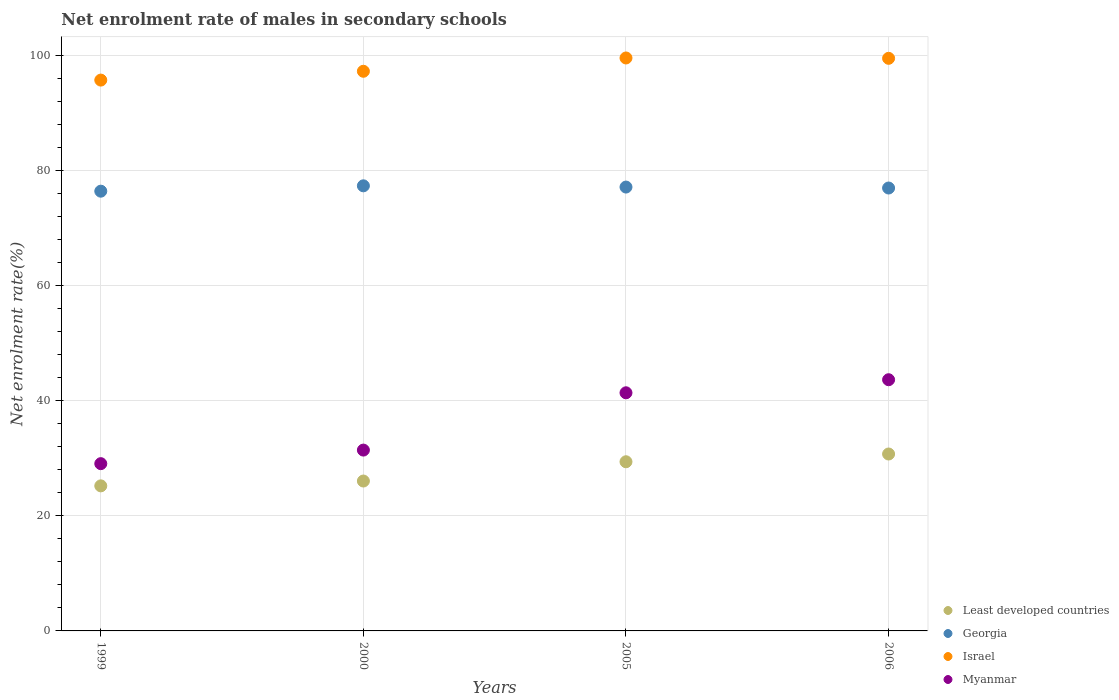What is the net enrolment rate of males in secondary schools in Israel in 2005?
Make the answer very short. 99.56. Across all years, what is the maximum net enrolment rate of males in secondary schools in Myanmar?
Ensure brevity in your answer.  43.65. Across all years, what is the minimum net enrolment rate of males in secondary schools in Least developed countries?
Your answer should be very brief. 25.21. What is the total net enrolment rate of males in secondary schools in Israel in the graph?
Ensure brevity in your answer.  392.01. What is the difference between the net enrolment rate of males in secondary schools in Georgia in 1999 and that in 2000?
Offer a very short reply. -0.93. What is the difference between the net enrolment rate of males in secondary schools in Georgia in 2006 and the net enrolment rate of males in secondary schools in Least developed countries in 2000?
Provide a short and direct response. 50.91. What is the average net enrolment rate of males in secondary schools in Israel per year?
Give a very brief answer. 98. In the year 2006, what is the difference between the net enrolment rate of males in secondary schools in Myanmar and net enrolment rate of males in secondary schools in Least developed countries?
Your answer should be compact. 12.91. What is the ratio of the net enrolment rate of males in secondary schools in Least developed countries in 2000 to that in 2005?
Your response must be concise. 0.89. Is the difference between the net enrolment rate of males in secondary schools in Myanmar in 2000 and 2006 greater than the difference between the net enrolment rate of males in secondary schools in Least developed countries in 2000 and 2006?
Your answer should be very brief. No. What is the difference between the highest and the second highest net enrolment rate of males in secondary schools in Least developed countries?
Your response must be concise. 1.35. What is the difference between the highest and the lowest net enrolment rate of males in secondary schools in Israel?
Ensure brevity in your answer.  3.84. Is it the case that in every year, the sum of the net enrolment rate of males in secondary schools in Least developed countries and net enrolment rate of males in secondary schools in Israel  is greater than the sum of net enrolment rate of males in secondary schools in Georgia and net enrolment rate of males in secondary schools in Myanmar?
Give a very brief answer. Yes. Is it the case that in every year, the sum of the net enrolment rate of males in secondary schools in Georgia and net enrolment rate of males in secondary schools in Israel  is greater than the net enrolment rate of males in secondary schools in Least developed countries?
Provide a short and direct response. Yes. Are the values on the major ticks of Y-axis written in scientific E-notation?
Provide a succinct answer. No. Where does the legend appear in the graph?
Provide a short and direct response. Bottom right. What is the title of the graph?
Offer a terse response. Net enrolment rate of males in secondary schools. Does "Australia" appear as one of the legend labels in the graph?
Provide a succinct answer. No. What is the label or title of the Y-axis?
Keep it short and to the point. Net enrolment rate(%). What is the Net enrolment rate(%) of Least developed countries in 1999?
Give a very brief answer. 25.21. What is the Net enrolment rate(%) in Georgia in 1999?
Provide a succinct answer. 76.41. What is the Net enrolment rate(%) in Israel in 1999?
Ensure brevity in your answer.  95.71. What is the Net enrolment rate(%) of Myanmar in 1999?
Ensure brevity in your answer.  29.06. What is the Net enrolment rate(%) of Least developed countries in 2000?
Ensure brevity in your answer.  26.05. What is the Net enrolment rate(%) in Georgia in 2000?
Your answer should be compact. 77.34. What is the Net enrolment rate(%) in Israel in 2000?
Ensure brevity in your answer.  97.25. What is the Net enrolment rate(%) in Myanmar in 2000?
Keep it short and to the point. 31.42. What is the Net enrolment rate(%) of Least developed countries in 2005?
Give a very brief answer. 29.39. What is the Net enrolment rate(%) of Georgia in 2005?
Offer a very short reply. 77.13. What is the Net enrolment rate(%) in Israel in 2005?
Provide a short and direct response. 99.56. What is the Net enrolment rate(%) in Myanmar in 2005?
Your response must be concise. 41.38. What is the Net enrolment rate(%) of Least developed countries in 2006?
Keep it short and to the point. 30.74. What is the Net enrolment rate(%) of Georgia in 2006?
Offer a terse response. 76.96. What is the Net enrolment rate(%) in Israel in 2006?
Make the answer very short. 99.5. What is the Net enrolment rate(%) of Myanmar in 2006?
Offer a very short reply. 43.65. Across all years, what is the maximum Net enrolment rate(%) of Least developed countries?
Keep it short and to the point. 30.74. Across all years, what is the maximum Net enrolment rate(%) of Georgia?
Keep it short and to the point. 77.34. Across all years, what is the maximum Net enrolment rate(%) of Israel?
Ensure brevity in your answer.  99.56. Across all years, what is the maximum Net enrolment rate(%) in Myanmar?
Provide a short and direct response. 43.65. Across all years, what is the minimum Net enrolment rate(%) in Least developed countries?
Your response must be concise. 25.21. Across all years, what is the minimum Net enrolment rate(%) of Georgia?
Your response must be concise. 76.41. Across all years, what is the minimum Net enrolment rate(%) in Israel?
Provide a short and direct response. 95.71. Across all years, what is the minimum Net enrolment rate(%) of Myanmar?
Make the answer very short. 29.06. What is the total Net enrolment rate(%) in Least developed countries in the graph?
Make the answer very short. 111.39. What is the total Net enrolment rate(%) of Georgia in the graph?
Provide a short and direct response. 307.84. What is the total Net enrolment rate(%) of Israel in the graph?
Keep it short and to the point. 392.01. What is the total Net enrolment rate(%) in Myanmar in the graph?
Ensure brevity in your answer.  145.51. What is the difference between the Net enrolment rate(%) of Least developed countries in 1999 and that in 2000?
Your answer should be very brief. -0.84. What is the difference between the Net enrolment rate(%) of Georgia in 1999 and that in 2000?
Keep it short and to the point. -0.93. What is the difference between the Net enrolment rate(%) in Israel in 1999 and that in 2000?
Offer a very short reply. -1.53. What is the difference between the Net enrolment rate(%) in Myanmar in 1999 and that in 2000?
Provide a short and direct response. -2.36. What is the difference between the Net enrolment rate(%) of Least developed countries in 1999 and that in 2005?
Provide a short and direct response. -4.19. What is the difference between the Net enrolment rate(%) in Georgia in 1999 and that in 2005?
Provide a succinct answer. -0.72. What is the difference between the Net enrolment rate(%) of Israel in 1999 and that in 2005?
Offer a very short reply. -3.84. What is the difference between the Net enrolment rate(%) of Myanmar in 1999 and that in 2005?
Provide a succinct answer. -12.31. What is the difference between the Net enrolment rate(%) of Least developed countries in 1999 and that in 2006?
Offer a terse response. -5.54. What is the difference between the Net enrolment rate(%) of Georgia in 1999 and that in 2006?
Provide a short and direct response. -0.55. What is the difference between the Net enrolment rate(%) in Israel in 1999 and that in 2006?
Provide a succinct answer. -3.78. What is the difference between the Net enrolment rate(%) in Myanmar in 1999 and that in 2006?
Offer a terse response. -14.58. What is the difference between the Net enrolment rate(%) of Least developed countries in 2000 and that in 2005?
Provide a succinct answer. -3.35. What is the difference between the Net enrolment rate(%) in Georgia in 2000 and that in 2005?
Provide a succinct answer. 0.22. What is the difference between the Net enrolment rate(%) in Israel in 2000 and that in 2005?
Your answer should be compact. -2.31. What is the difference between the Net enrolment rate(%) of Myanmar in 2000 and that in 2005?
Keep it short and to the point. -9.96. What is the difference between the Net enrolment rate(%) of Least developed countries in 2000 and that in 2006?
Your answer should be compact. -4.7. What is the difference between the Net enrolment rate(%) of Georgia in 2000 and that in 2006?
Your answer should be compact. 0.38. What is the difference between the Net enrolment rate(%) of Israel in 2000 and that in 2006?
Give a very brief answer. -2.25. What is the difference between the Net enrolment rate(%) of Myanmar in 2000 and that in 2006?
Give a very brief answer. -12.23. What is the difference between the Net enrolment rate(%) of Least developed countries in 2005 and that in 2006?
Your response must be concise. -1.35. What is the difference between the Net enrolment rate(%) of Georgia in 2005 and that in 2006?
Provide a succinct answer. 0.17. What is the difference between the Net enrolment rate(%) in Israel in 2005 and that in 2006?
Offer a terse response. 0.06. What is the difference between the Net enrolment rate(%) in Myanmar in 2005 and that in 2006?
Provide a succinct answer. -2.27. What is the difference between the Net enrolment rate(%) in Least developed countries in 1999 and the Net enrolment rate(%) in Georgia in 2000?
Your answer should be compact. -52.14. What is the difference between the Net enrolment rate(%) of Least developed countries in 1999 and the Net enrolment rate(%) of Israel in 2000?
Your answer should be compact. -72.04. What is the difference between the Net enrolment rate(%) of Least developed countries in 1999 and the Net enrolment rate(%) of Myanmar in 2000?
Keep it short and to the point. -6.22. What is the difference between the Net enrolment rate(%) in Georgia in 1999 and the Net enrolment rate(%) in Israel in 2000?
Make the answer very short. -20.84. What is the difference between the Net enrolment rate(%) in Georgia in 1999 and the Net enrolment rate(%) in Myanmar in 2000?
Your answer should be very brief. 44.99. What is the difference between the Net enrolment rate(%) in Israel in 1999 and the Net enrolment rate(%) in Myanmar in 2000?
Make the answer very short. 64.29. What is the difference between the Net enrolment rate(%) in Least developed countries in 1999 and the Net enrolment rate(%) in Georgia in 2005?
Keep it short and to the point. -51.92. What is the difference between the Net enrolment rate(%) in Least developed countries in 1999 and the Net enrolment rate(%) in Israel in 2005?
Ensure brevity in your answer.  -74.35. What is the difference between the Net enrolment rate(%) of Least developed countries in 1999 and the Net enrolment rate(%) of Myanmar in 2005?
Provide a succinct answer. -16.17. What is the difference between the Net enrolment rate(%) of Georgia in 1999 and the Net enrolment rate(%) of Israel in 2005?
Keep it short and to the point. -23.15. What is the difference between the Net enrolment rate(%) in Georgia in 1999 and the Net enrolment rate(%) in Myanmar in 2005?
Your answer should be very brief. 35.03. What is the difference between the Net enrolment rate(%) of Israel in 1999 and the Net enrolment rate(%) of Myanmar in 2005?
Provide a succinct answer. 54.34. What is the difference between the Net enrolment rate(%) of Least developed countries in 1999 and the Net enrolment rate(%) of Georgia in 2006?
Your answer should be compact. -51.75. What is the difference between the Net enrolment rate(%) of Least developed countries in 1999 and the Net enrolment rate(%) of Israel in 2006?
Provide a short and direct response. -74.29. What is the difference between the Net enrolment rate(%) in Least developed countries in 1999 and the Net enrolment rate(%) in Myanmar in 2006?
Keep it short and to the point. -18.44. What is the difference between the Net enrolment rate(%) of Georgia in 1999 and the Net enrolment rate(%) of Israel in 2006?
Provide a short and direct response. -23.09. What is the difference between the Net enrolment rate(%) of Georgia in 1999 and the Net enrolment rate(%) of Myanmar in 2006?
Ensure brevity in your answer.  32.76. What is the difference between the Net enrolment rate(%) of Israel in 1999 and the Net enrolment rate(%) of Myanmar in 2006?
Make the answer very short. 52.06. What is the difference between the Net enrolment rate(%) of Least developed countries in 2000 and the Net enrolment rate(%) of Georgia in 2005?
Provide a succinct answer. -51.08. What is the difference between the Net enrolment rate(%) in Least developed countries in 2000 and the Net enrolment rate(%) in Israel in 2005?
Offer a terse response. -73.51. What is the difference between the Net enrolment rate(%) in Least developed countries in 2000 and the Net enrolment rate(%) in Myanmar in 2005?
Your answer should be very brief. -15.33. What is the difference between the Net enrolment rate(%) of Georgia in 2000 and the Net enrolment rate(%) of Israel in 2005?
Give a very brief answer. -22.22. What is the difference between the Net enrolment rate(%) in Georgia in 2000 and the Net enrolment rate(%) in Myanmar in 2005?
Your answer should be compact. 35.96. What is the difference between the Net enrolment rate(%) of Israel in 2000 and the Net enrolment rate(%) of Myanmar in 2005?
Provide a succinct answer. 55.87. What is the difference between the Net enrolment rate(%) in Least developed countries in 2000 and the Net enrolment rate(%) in Georgia in 2006?
Your response must be concise. -50.91. What is the difference between the Net enrolment rate(%) of Least developed countries in 2000 and the Net enrolment rate(%) of Israel in 2006?
Your response must be concise. -73.45. What is the difference between the Net enrolment rate(%) of Least developed countries in 2000 and the Net enrolment rate(%) of Myanmar in 2006?
Give a very brief answer. -17.6. What is the difference between the Net enrolment rate(%) of Georgia in 2000 and the Net enrolment rate(%) of Israel in 2006?
Make the answer very short. -22.16. What is the difference between the Net enrolment rate(%) of Georgia in 2000 and the Net enrolment rate(%) of Myanmar in 2006?
Provide a succinct answer. 33.69. What is the difference between the Net enrolment rate(%) in Israel in 2000 and the Net enrolment rate(%) in Myanmar in 2006?
Make the answer very short. 53.6. What is the difference between the Net enrolment rate(%) of Least developed countries in 2005 and the Net enrolment rate(%) of Georgia in 2006?
Keep it short and to the point. -47.56. What is the difference between the Net enrolment rate(%) in Least developed countries in 2005 and the Net enrolment rate(%) in Israel in 2006?
Ensure brevity in your answer.  -70.1. What is the difference between the Net enrolment rate(%) in Least developed countries in 2005 and the Net enrolment rate(%) in Myanmar in 2006?
Provide a short and direct response. -14.25. What is the difference between the Net enrolment rate(%) of Georgia in 2005 and the Net enrolment rate(%) of Israel in 2006?
Offer a very short reply. -22.37. What is the difference between the Net enrolment rate(%) in Georgia in 2005 and the Net enrolment rate(%) in Myanmar in 2006?
Make the answer very short. 33.48. What is the difference between the Net enrolment rate(%) in Israel in 2005 and the Net enrolment rate(%) in Myanmar in 2006?
Keep it short and to the point. 55.91. What is the average Net enrolment rate(%) of Least developed countries per year?
Your answer should be compact. 27.85. What is the average Net enrolment rate(%) of Georgia per year?
Your response must be concise. 76.96. What is the average Net enrolment rate(%) of Israel per year?
Provide a short and direct response. 98. What is the average Net enrolment rate(%) in Myanmar per year?
Make the answer very short. 36.38. In the year 1999, what is the difference between the Net enrolment rate(%) of Least developed countries and Net enrolment rate(%) of Georgia?
Make the answer very short. -51.2. In the year 1999, what is the difference between the Net enrolment rate(%) in Least developed countries and Net enrolment rate(%) in Israel?
Ensure brevity in your answer.  -70.51. In the year 1999, what is the difference between the Net enrolment rate(%) in Least developed countries and Net enrolment rate(%) in Myanmar?
Offer a terse response. -3.86. In the year 1999, what is the difference between the Net enrolment rate(%) in Georgia and Net enrolment rate(%) in Israel?
Offer a very short reply. -19.3. In the year 1999, what is the difference between the Net enrolment rate(%) in Georgia and Net enrolment rate(%) in Myanmar?
Provide a short and direct response. 47.35. In the year 1999, what is the difference between the Net enrolment rate(%) of Israel and Net enrolment rate(%) of Myanmar?
Make the answer very short. 66.65. In the year 2000, what is the difference between the Net enrolment rate(%) of Least developed countries and Net enrolment rate(%) of Georgia?
Make the answer very short. -51.3. In the year 2000, what is the difference between the Net enrolment rate(%) in Least developed countries and Net enrolment rate(%) in Israel?
Offer a terse response. -71.2. In the year 2000, what is the difference between the Net enrolment rate(%) in Least developed countries and Net enrolment rate(%) in Myanmar?
Give a very brief answer. -5.38. In the year 2000, what is the difference between the Net enrolment rate(%) of Georgia and Net enrolment rate(%) of Israel?
Your answer should be compact. -19.91. In the year 2000, what is the difference between the Net enrolment rate(%) in Georgia and Net enrolment rate(%) in Myanmar?
Your answer should be very brief. 45.92. In the year 2000, what is the difference between the Net enrolment rate(%) of Israel and Net enrolment rate(%) of Myanmar?
Give a very brief answer. 65.83. In the year 2005, what is the difference between the Net enrolment rate(%) in Least developed countries and Net enrolment rate(%) in Georgia?
Your response must be concise. -47.73. In the year 2005, what is the difference between the Net enrolment rate(%) in Least developed countries and Net enrolment rate(%) in Israel?
Offer a very short reply. -70.16. In the year 2005, what is the difference between the Net enrolment rate(%) of Least developed countries and Net enrolment rate(%) of Myanmar?
Your answer should be compact. -11.98. In the year 2005, what is the difference between the Net enrolment rate(%) in Georgia and Net enrolment rate(%) in Israel?
Give a very brief answer. -22.43. In the year 2005, what is the difference between the Net enrolment rate(%) of Georgia and Net enrolment rate(%) of Myanmar?
Ensure brevity in your answer.  35.75. In the year 2005, what is the difference between the Net enrolment rate(%) in Israel and Net enrolment rate(%) in Myanmar?
Offer a very short reply. 58.18. In the year 2006, what is the difference between the Net enrolment rate(%) of Least developed countries and Net enrolment rate(%) of Georgia?
Offer a terse response. -46.22. In the year 2006, what is the difference between the Net enrolment rate(%) of Least developed countries and Net enrolment rate(%) of Israel?
Your answer should be compact. -68.76. In the year 2006, what is the difference between the Net enrolment rate(%) in Least developed countries and Net enrolment rate(%) in Myanmar?
Ensure brevity in your answer.  -12.91. In the year 2006, what is the difference between the Net enrolment rate(%) of Georgia and Net enrolment rate(%) of Israel?
Offer a very short reply. -22.54. In the year 2006, what is the difference between the Net enrolment rate(%) of Georgia and Net enrolment rate(%) of Myanmar?
Offer a terse response. 33.31. In the year 2006, what is the difference between the Net enrolment rate(%) in Israel and Net enrolment rate(%) in Myanmar?
Your answer should be compact. 55.85. What is the ratio of the Net enrolment rate(%) of Least developed countries in 1999 to that in 2000?
Offer a very short reply. 0.97. What is the ratio of the Net enrolment rate(%) of Israel in 1999 to that in 2000?
Ensure brevity in your answer.  0.98. What is the ratio of the Net enrolment rate(%) in Myanmar in 1999 to that in 2000?
Make the answer very short. 0.93. What is the ratio of the Net enrolment rate(%) of Least developed countries in 1999 to that in 2005?
Ensure brevity in your answer.  0.86. What is the ratio of the Net enrolment rate(%) of Israel in 1999 to that in 2005?
Keep it short and to the point. 0.96. What is the ratio of the Net enrolment rate(%) in Myanmar in 1999 to that in 2005?
Your answer should be compact. 0.7. What is the ratio of the Net enrolment rate(%) of Least developed countries in 1999 to that in 2006?
Provide a succinct answer. 0.82. What is the ratio of the Net enrolment rate(%) in Georgia in 1999 to that in 2006?
Provide a short and direct response. 0.99. What is the ratio of the Net enrolment rate(%) of Israel in 1999 to that in 2006?
Your answer should be compact. 0.96. What is the ratio of the Net enrolment rate(%) in Myanmar in 1999 to that in 2006?
Give a very brief answer. 0.67. What is the ratio of the Net enrolment rate(%) in Least developed countries in 2000 to that in 2005?
Provide a succinct answer. 0.89. What is the ratio of the Net enrolment rate(%) of Georgia in 2000 to that in 2005?
Your answer should be compact. 1. What is the ratio of the Net enrolment rate(%) in Israel in 2000 to that in 2005?
Keep it short and to the point. 0.98. What is the ratio of the Net enrolment rate(%) in Myanmar in 2000 to that in 2005?
Make the answer very short. 0.76. What is the ratio of the Net enrolment rate(%) of Least developed countries in 2000 to that in 2006?
Your response must be concise. 0.85. What is the ratio of the Net enrolment rate(%) in Israel in 2000 to that in 2006?
Provide a short and direct response. 0.98. What is the ratio of the Net enrolment rate(%) in Myanmar in 2000 to that in 2006?
Ensure brevity in your answer.  0.72. What is the ratio of the Net enrolment rate(%) of Least developed countries in 2005 to that in 2006?
Offer a terse response. 0.96. What is the ratio of the Net enrolment rate(%) of Israel in 2005 to that in 2006?
Make the answer very short. 1. What is the ratio of the Net enrolment rate(%) in Myanmar in 2005 to that in 2006?
Keep it short and to the point. 0.95. What is the difference between the highest and the second highest Net enrolment rate(%) of Least developed countries?
Ensure brevity in your answer.  1.35. What is the difference between the highest and the second highest Net enrolment rate(%) of Georgia?
Keep it short and to the point. 0.22. What is the difference between the highest and the second highest Net enrolment rate(%) in Israel?
Your answer should be very brief. 0.06. What is the difference between the highest and the second highest Net enrolment rate(%) of Myanmar?
Make the answer very short. 2.27. What is the difference between the highest and the lowest Net enrolment rate(%) in Least developed countries?
Provide a succinct answer. 5.54. What is the difference between the highest and the lowest Net enrolment rate(%) of Georgia?
Your answer should be compact. 0.93. What is the difference between the highest and the lowest Net enrolment rate(%) in Israel?
Keep it short and to the point. 3.84. What is the difference between the highest and the lowest Net enrolment rate(%) in Myanmar?
Keep it short and to the point. 14.58. 